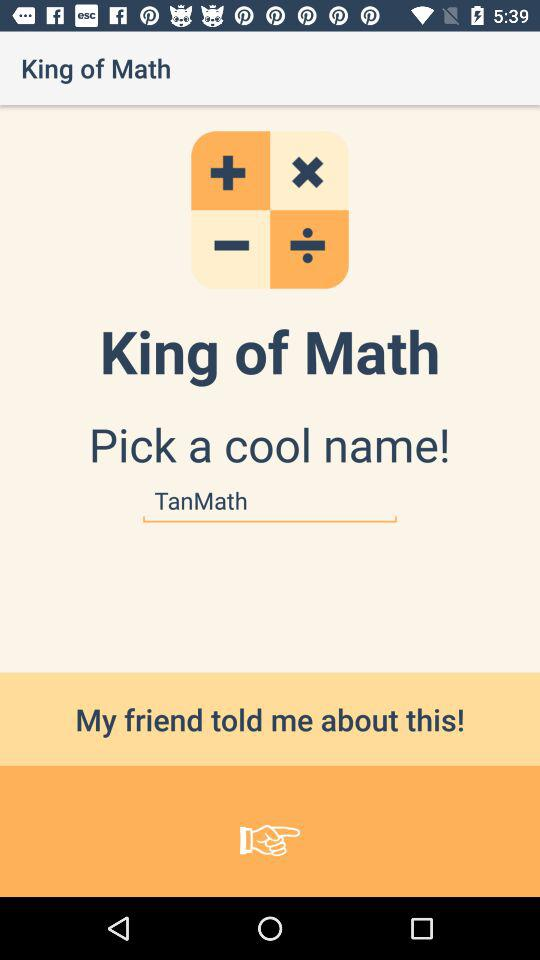Which version of "King of Math" is this?
When the provided information is insufficient, respond with <no answer>. <no answer> 